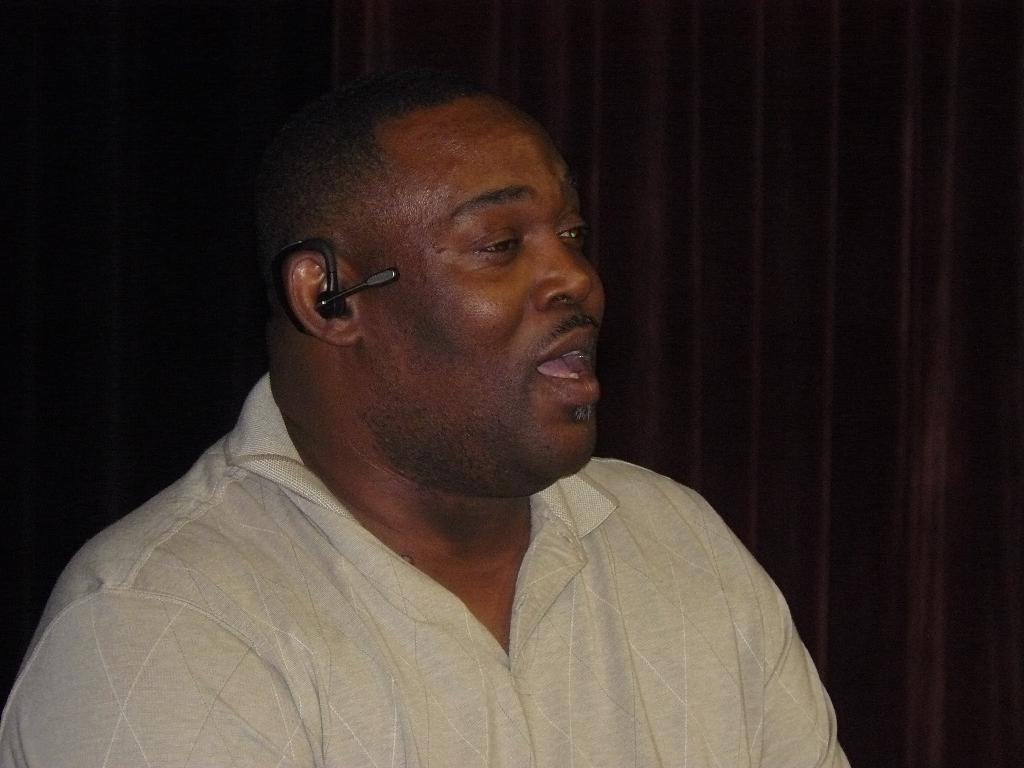Can you describe this image briefly? In this image we can see a person wearing a Bluetooth earphone. On the backside we can see a curtain. 